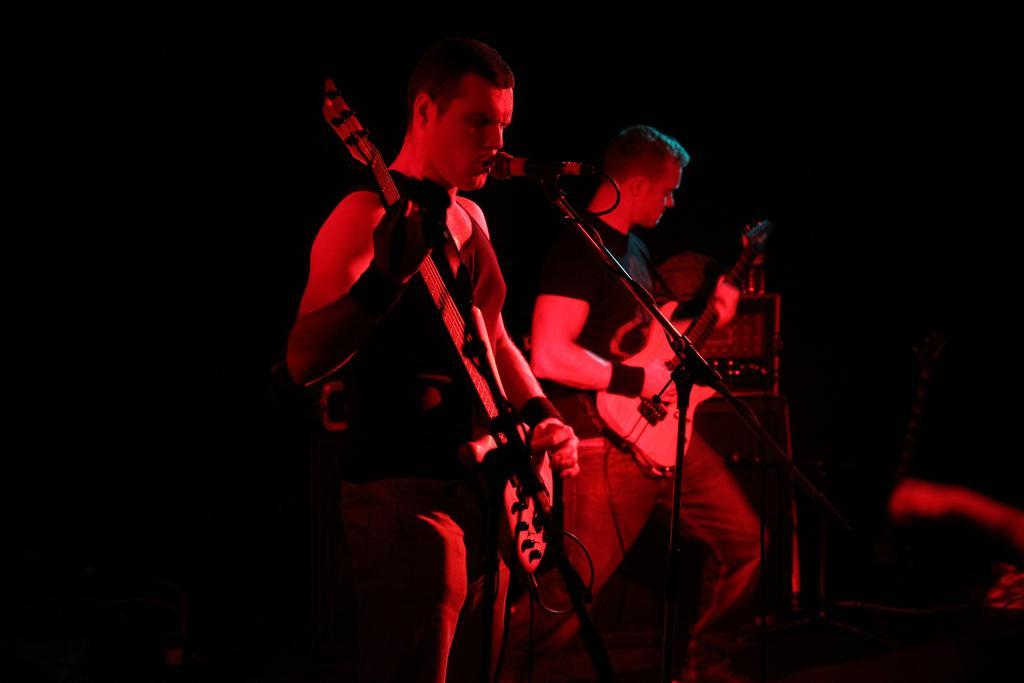Describe this image in one or two sentences. In this image there two men who are playing the guitar and there is a mic in front of them. 